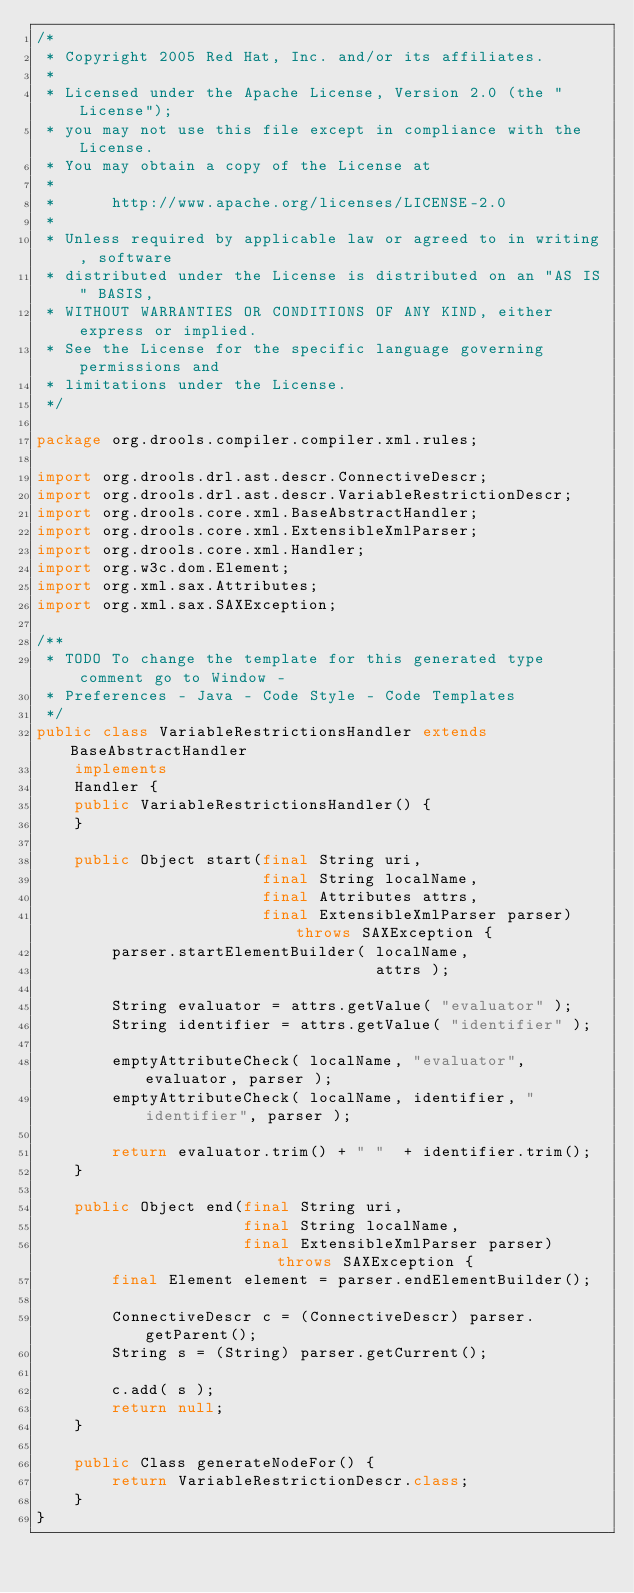<code> <loc_0><loc_0><loc_500><loc_500><_Java_>/*
 * Copyright 2005 Red Hat, Inc. and/or its affiliates.
 *
 * Licensed under the Apache License, Version 2.0 (the "License");
 * you may not use this file except in compliance with the License.
 * You may obtain a copy of the License at
 *
 *      http://www.apache.org/licenses/LICENSE-2.0
 *
 * Unless required by applicable law or agreed to in writing, software
 * distributed under the License is distributed on an "AS IS" BASIS,
 * WITHOUT WARRANTIES OR CONDITIONS OF ANY KIND, either express or implied.
 * See the License for the specific language governing permissions and
 * limitations under the License.
 */

package org.drools.compiler.compiler.xml.rules;

import org.drools.drl.ast.descr.ConnectiveDescr;
import org.drools.drl.ast.descr.VariableRestrictionDescr;
import org.drools.core.xml.BaseAbstractHandler;
import org.drools.core.xml.ExtensibleXmlParser;
import org.drools.core.xml.Handler;
import org.w3c.dom.Element;
import org.xml.sax.Attributes;
import org.xml.sax.SAXException;

/**
 * TODO To change the template for this generated type comment go to Window -
 * Preferences - Java - Code Style - Code Templates
 */
public class VariableRestrictionsHandler extends BaseAbstractHandler
    implements
    Handler {
    public VariableRestrictionsHandler() {
    }

    public Object start(final String uri,
                        final String localName,
                        final Attributes attrs,
                        final ExtensibleXmlParser parser) throws SAXException {
        parser.startElementBuilder( localName,
                                    attrs );

        String evaluator = attrs.getValue( "evaluator" );
        String identifier = attrs.getValue( "identifier" );
        
        emptyAttributeCheck( localName, "evaluator", evaluator, parser );
        emptyAttributeCheck( localName, identifier, "identifier", parser );
        
        return evaluator.trim() + " "  + identifier.trim();        
    }

    public Object end(final String uri,
                      final String localName,
                      final ExtensibleXmlParser parser) throws SAXException {
        final Element element = parser.endElementBuilder();
        
        ConnectiveDescr c = (ConnectiveDescr) parser.getParent();
        String s = (String) parser.getCurrent();

        c.add( s );
        return null;
    }

    public Class generateNodeFor() {
        return VariableRestrictionDescr.class;
    }
}
</code> 